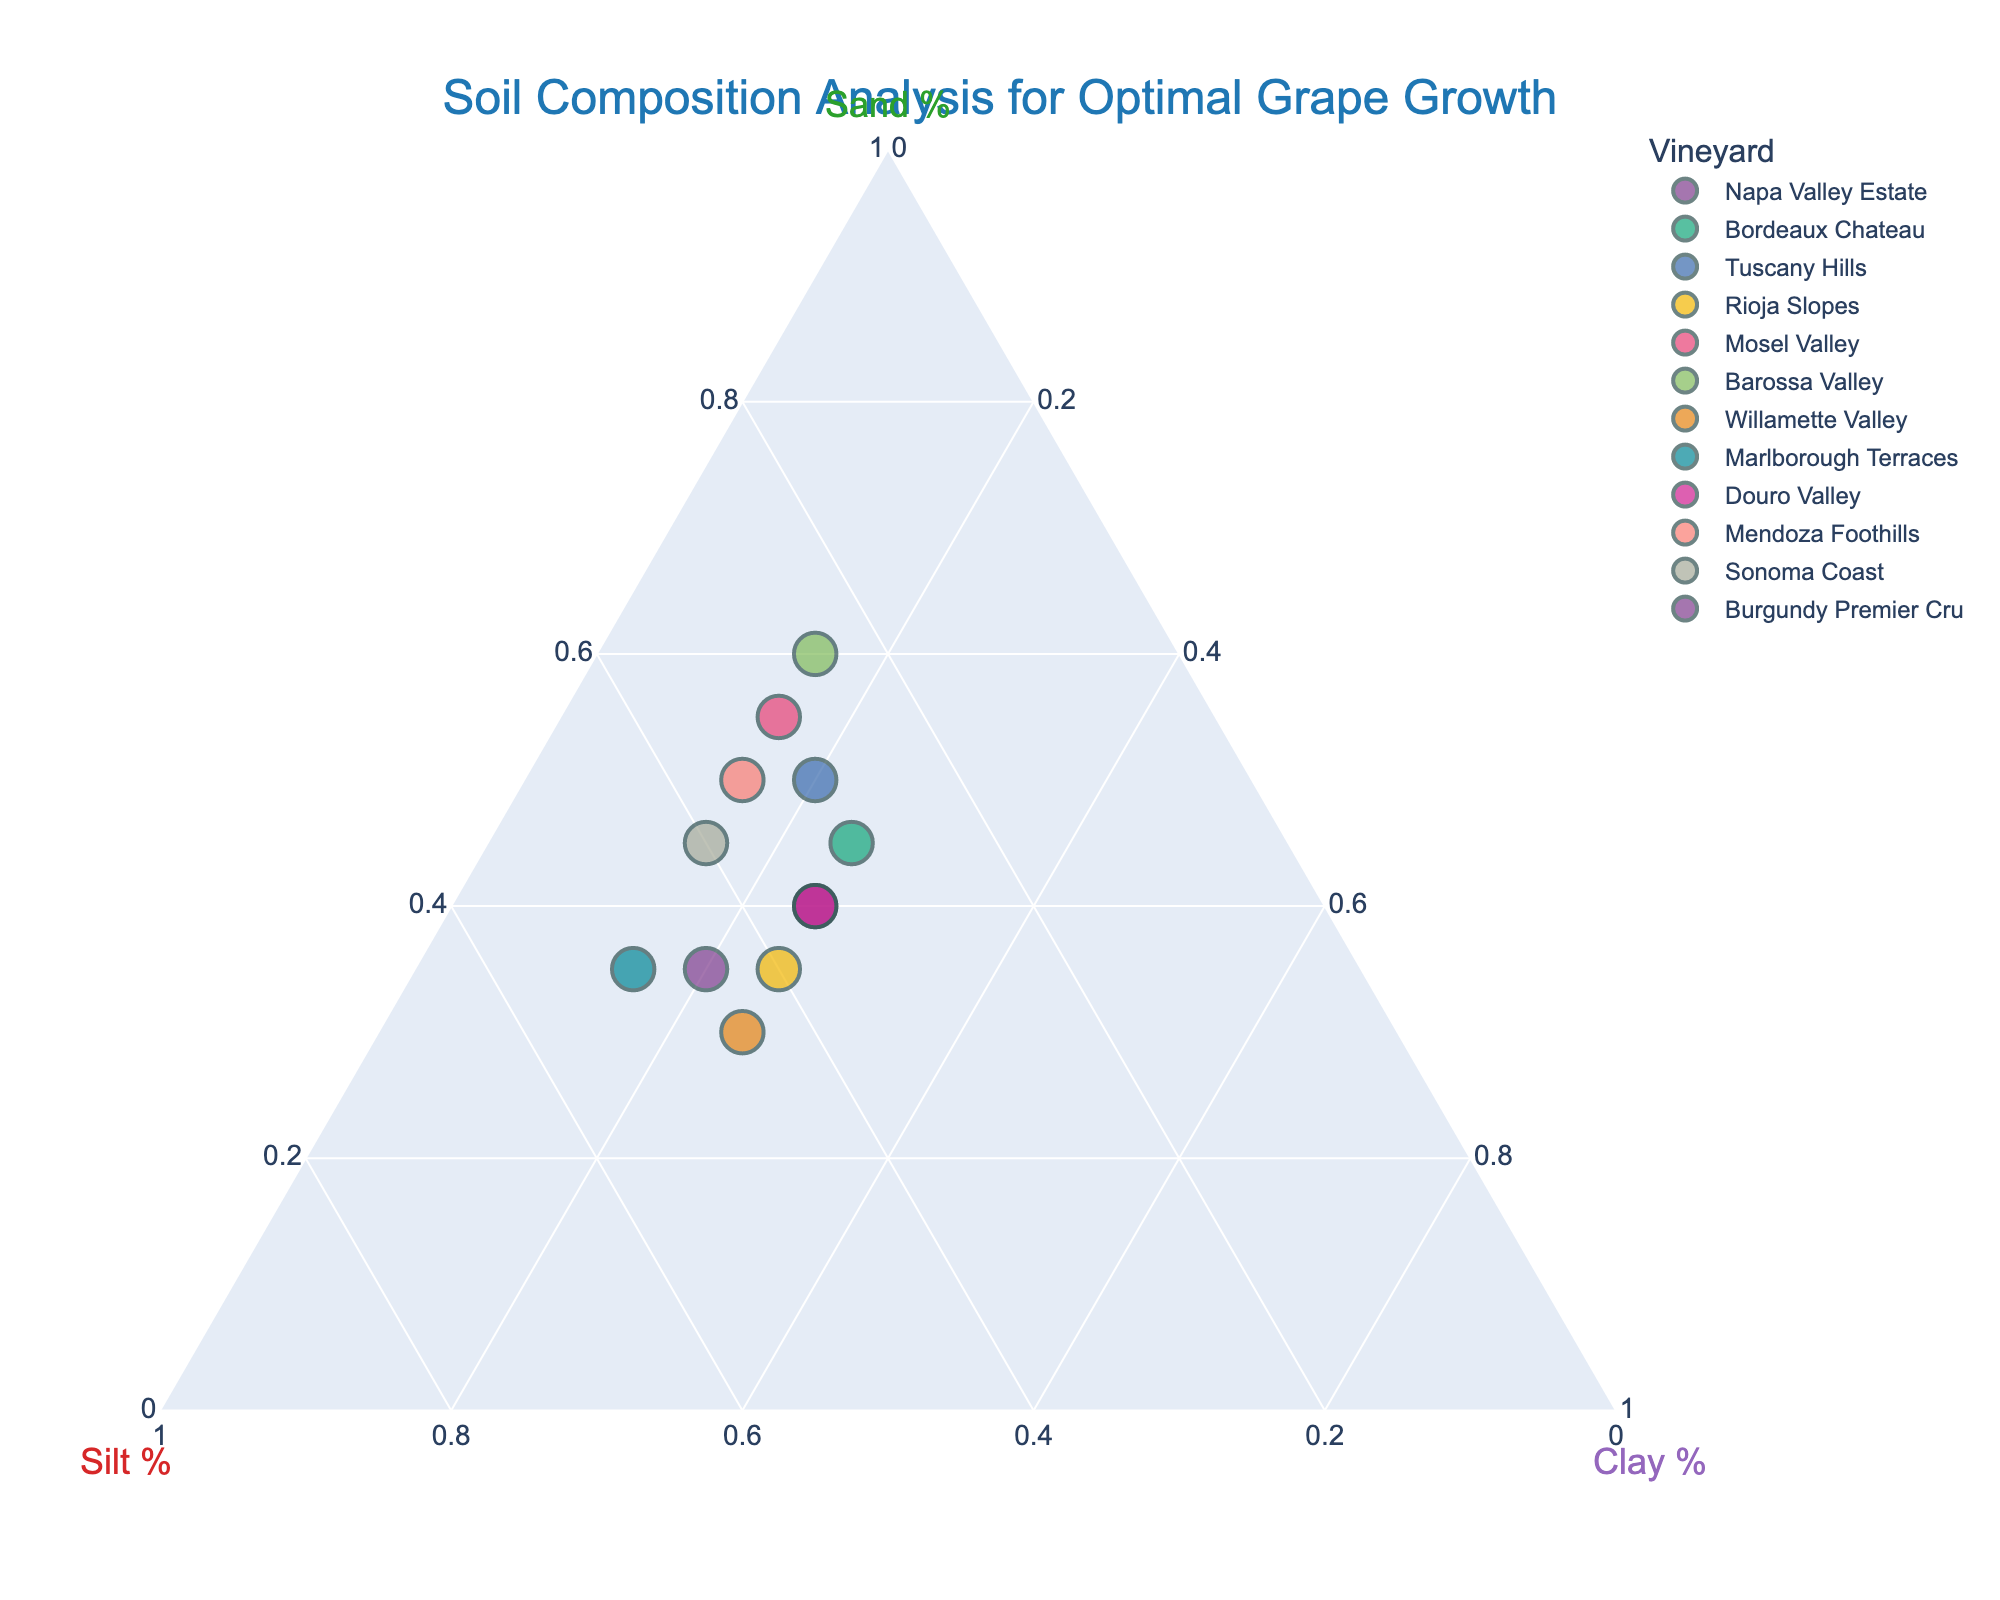what is the title of the figure? The title of the figure is displayed prominently at the top of the plot. By looking at the plot, you can see the title text.
Answer: Soil Composition Analysis for Optimal Grape Growth Which vineyard has the highest percentage of sand? By visually inspecting the points in the ternary plot and checking the Sand % axis, you identify the point closest to 100% Sand. This point corresponds to the vineyard with the highest percentage of sand.
Answer: Barossa Valley What's the range of Silt % in the data? To find the range, you identify the smallest and largest percentages of Silt in the dataset. The smallest is 25% (Barossa Valley and Mosel Valley), and the largest is 50% (Marlborough Terraces). Calculating the range: 50% - 25% = 25%.
Answer: 25% Which vineyards have the same soil composition? By analyzing the plot, you can see if any points overlap (indicating identical compositions of Sand, Silt, and Clay). Napa Valley Estate and Douro Valley both have 40% Sand, 35% Silt, and 25% Clay.
Answer: Napa Valley Estate and Douro Valley Which vineyards have more than 40% clay? By referencing the Clay % axis, check which points lie above the 40% mark. No points are above 40% Clay in the dataset, so no vineyard meets this criterion.
Answer: None Which vineyard has the closest soil composition to Tuscany Hills? By comparing the point for Tuscany Hills with other nearby points on the ternary plot, you can find the vineyard with the closest percentages. Napa Valley Estate and Douro Valley (both with 40% Sand, 35% Silt, 25% Clay) are closest to Tuscany Hills (50% Sand, 30% Silt, 20% Clay).
Answer: Napa Valley Estate and Douro Valley What's the median percentage of Clay across all vineyards? First, list all clay percentages: 15, 15, 15, 15, 15, 20, 20, 25, 25, 25, 25, 25. With 12 data points, the median is the average of the 6th and 7th values. Both are 20%, so the median is 20%.
Answer: 20% Which vineyard has the most balanced soil composition between Sand, Silt, and Clay? Balanced composition implies that the percentages of Sand, Silt, and Clay are close to each other. Bordeaux Chateau with 45% Sand, 30% Silt, and 25% Clay has the closest distribution.
Answer: Bordeaux Chateau Which regions have a higher percentage of silt than Mendoza Foothills? Comparing the silt percentage of Mendoza Foothills (35%) to other vineyards, Rioja Slopes (40%), Willamette Valley (45%), Marlborough Terraces (50%), Sonoma Coast (40%), and Burgundy Premier Cru (45%) all have higher silt percentages.
Answer: Rioja Slopes, Willamette Valley, Marlborough Terraces, Sonoma Coast, Burgundy Premier Cru 